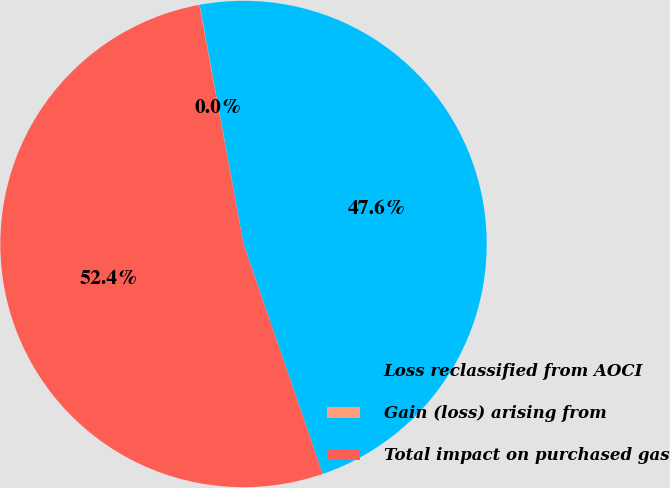Convert chart to OTSL. <chart><loc_0><loc_0><loc_500><loc_500><pie_chart><fcel>Loss reclassified from AOCI<fcel>Gain (loss) arising from<fcel>Total impact on purchased gas<nl><fcel>47.61%<fcel>0.02%<fcel>52.37%<nl></chart> 